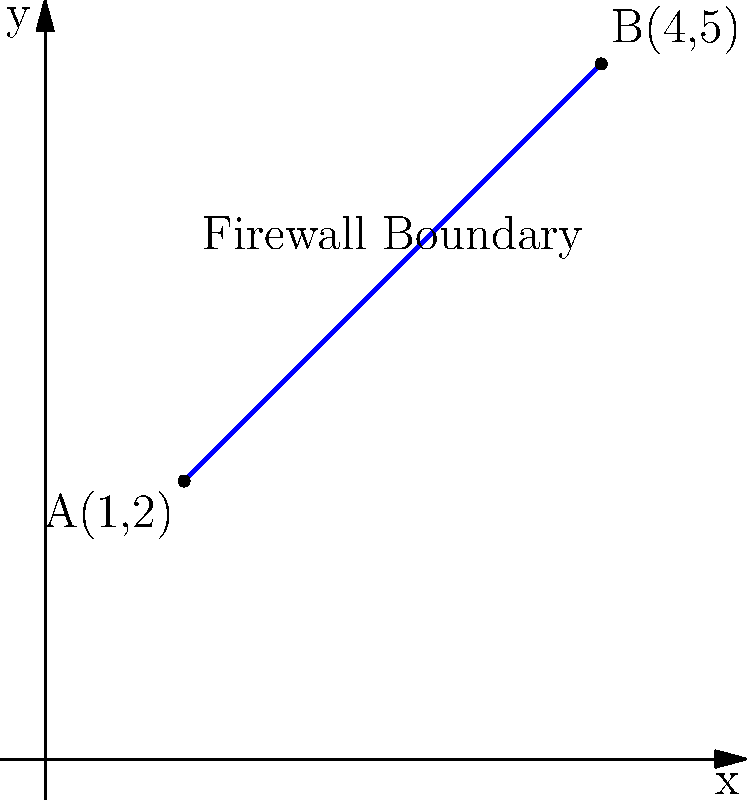As an IT specialist implementing a new firewall, you need to define its boundary mathematically. Given two points on the network topology, A(1,2) and B(4,5), determine the equation of the line representing the firewall boundary passing through these points. Express your answer in slope-intercept form $(y = mx + b)$. To find the equation of the line passing through two points, we can follow these steps:

1. Calculate the slope $(m)$ using the slope formula:
   $m = \frac{y_2 - y_1}{x_2 - x_1} = \frac{5 - 2}{4 - 1} = \frac{3}{3} = 1$

2. Use the point-slope form of a line equation:
   $y - y_1 = m(x - x_1)$

3. Substitute the slope and the coordinates of point A(1,2):
   $y - 2 = 1(x - 1)$

4. Expand the equation:
   $y - 2 = x - 1$

5. Solve for $y$ to get the slope-intercept form:
   $y = x - 1 + 2$
   $y = x + 1$

Therefore, the equation of the firewall boundary line in slope-intercept form is $y = x + 1$.
Answer: $y = x + 1$ 